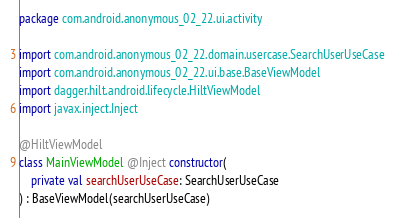Convert code to text. <code><loc_0><loc_0><loc_500><loc_500><_Kotlin_>package com.android.anonymous_02_22.ui.activity

import com.android.anonymous_02_22.domain.usercase.SearchUserUseCase
import com.android.anonymous_02_22.ui.base.BaseViewModel
import dagger.hilt.android.lifecycle.HiltViewModel
import javax.inject.Inject

@HiltViewModel
class MainViewModel @Inject constructor(
    private val searchUserUseCase: SearchUserUseCase
) : BaseViewModel(searchUserUseCase)</code> 